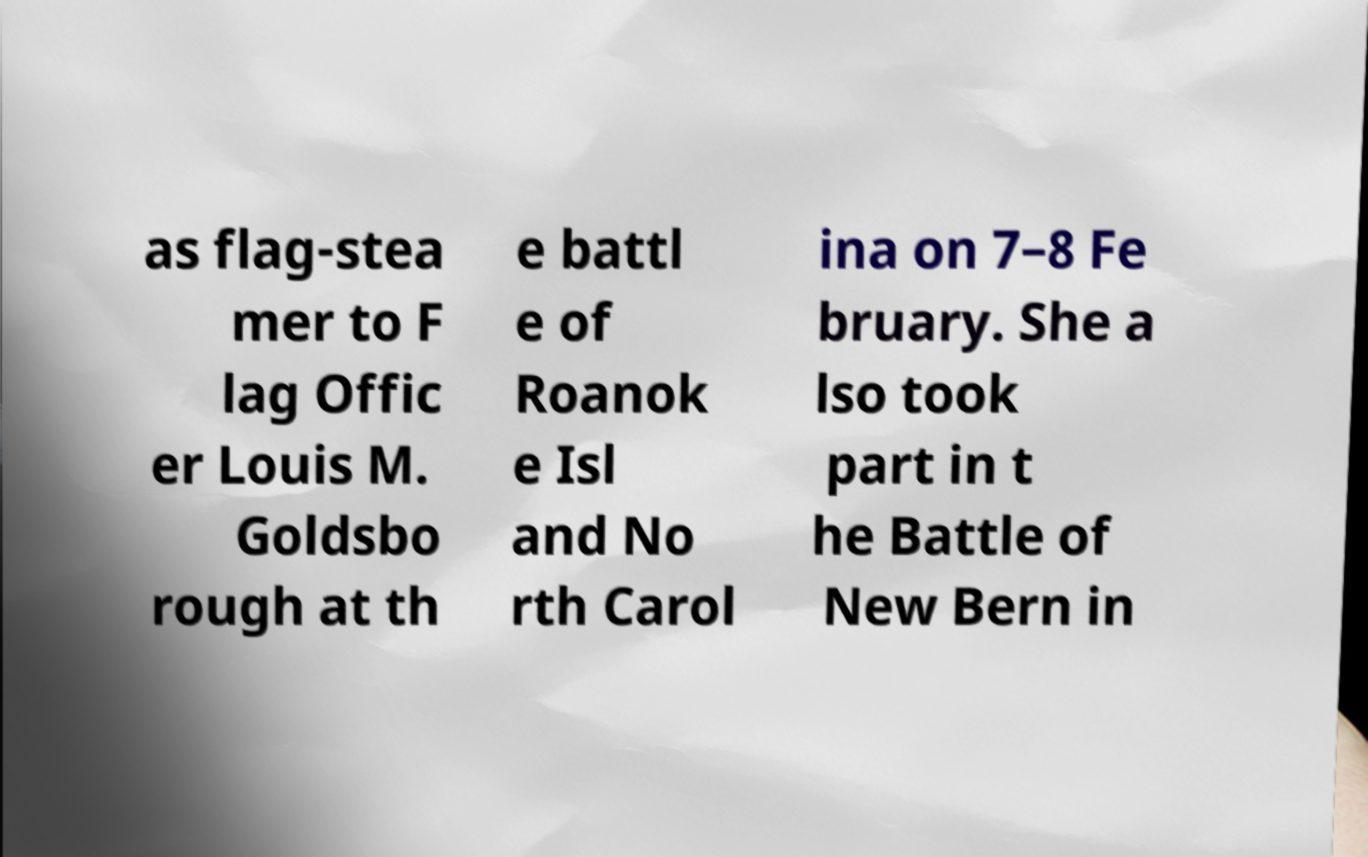Can you read and provide the text displayed in the image?This photo seems to have some interesting text. Can you extract and type it out for me? as flag-stea mer to F lag Offic er Louis M. Goldsbo rough at th e battl e of Roanok e Isl and No rth Carol ina on 7–8 Fe bruary. She a lso took part in t he Battle of New Bern in 